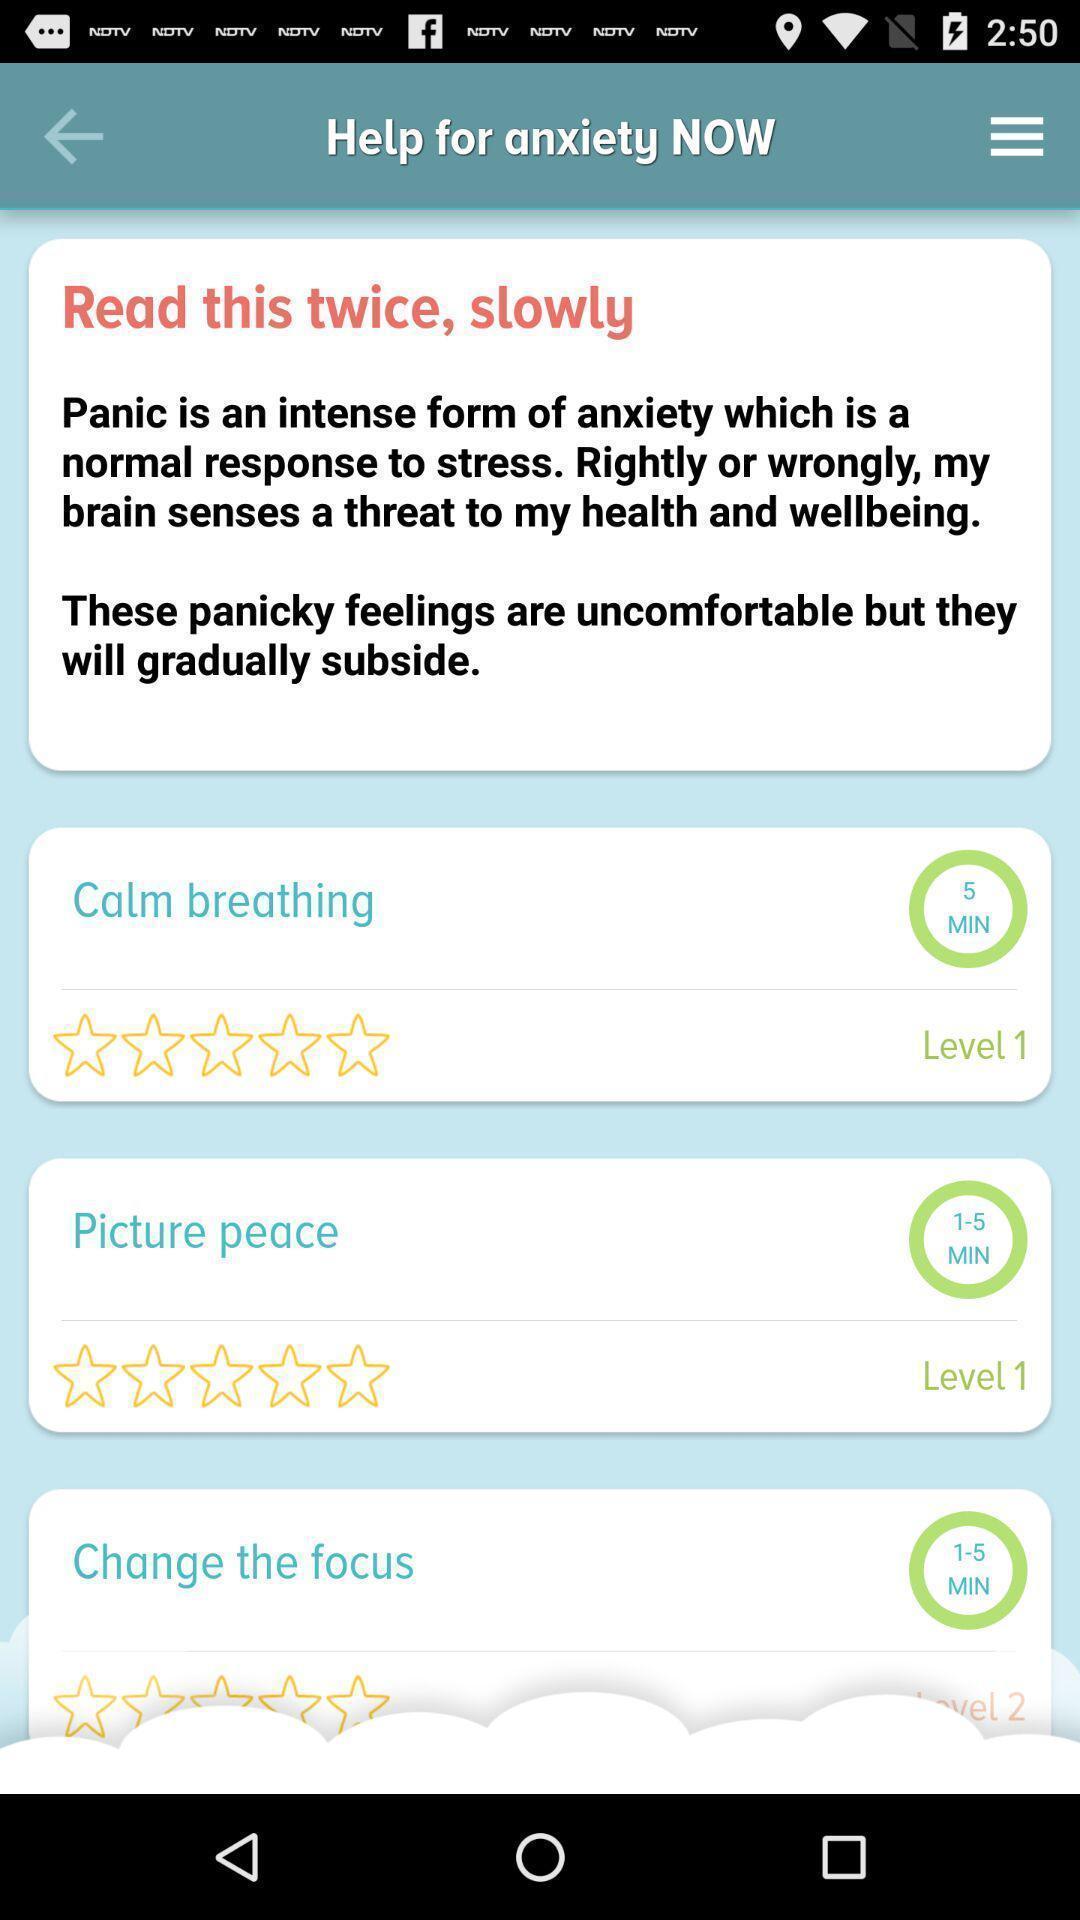What is the overall content of this screenshot? Various gimmicks displayed for a health care hygiene app. 